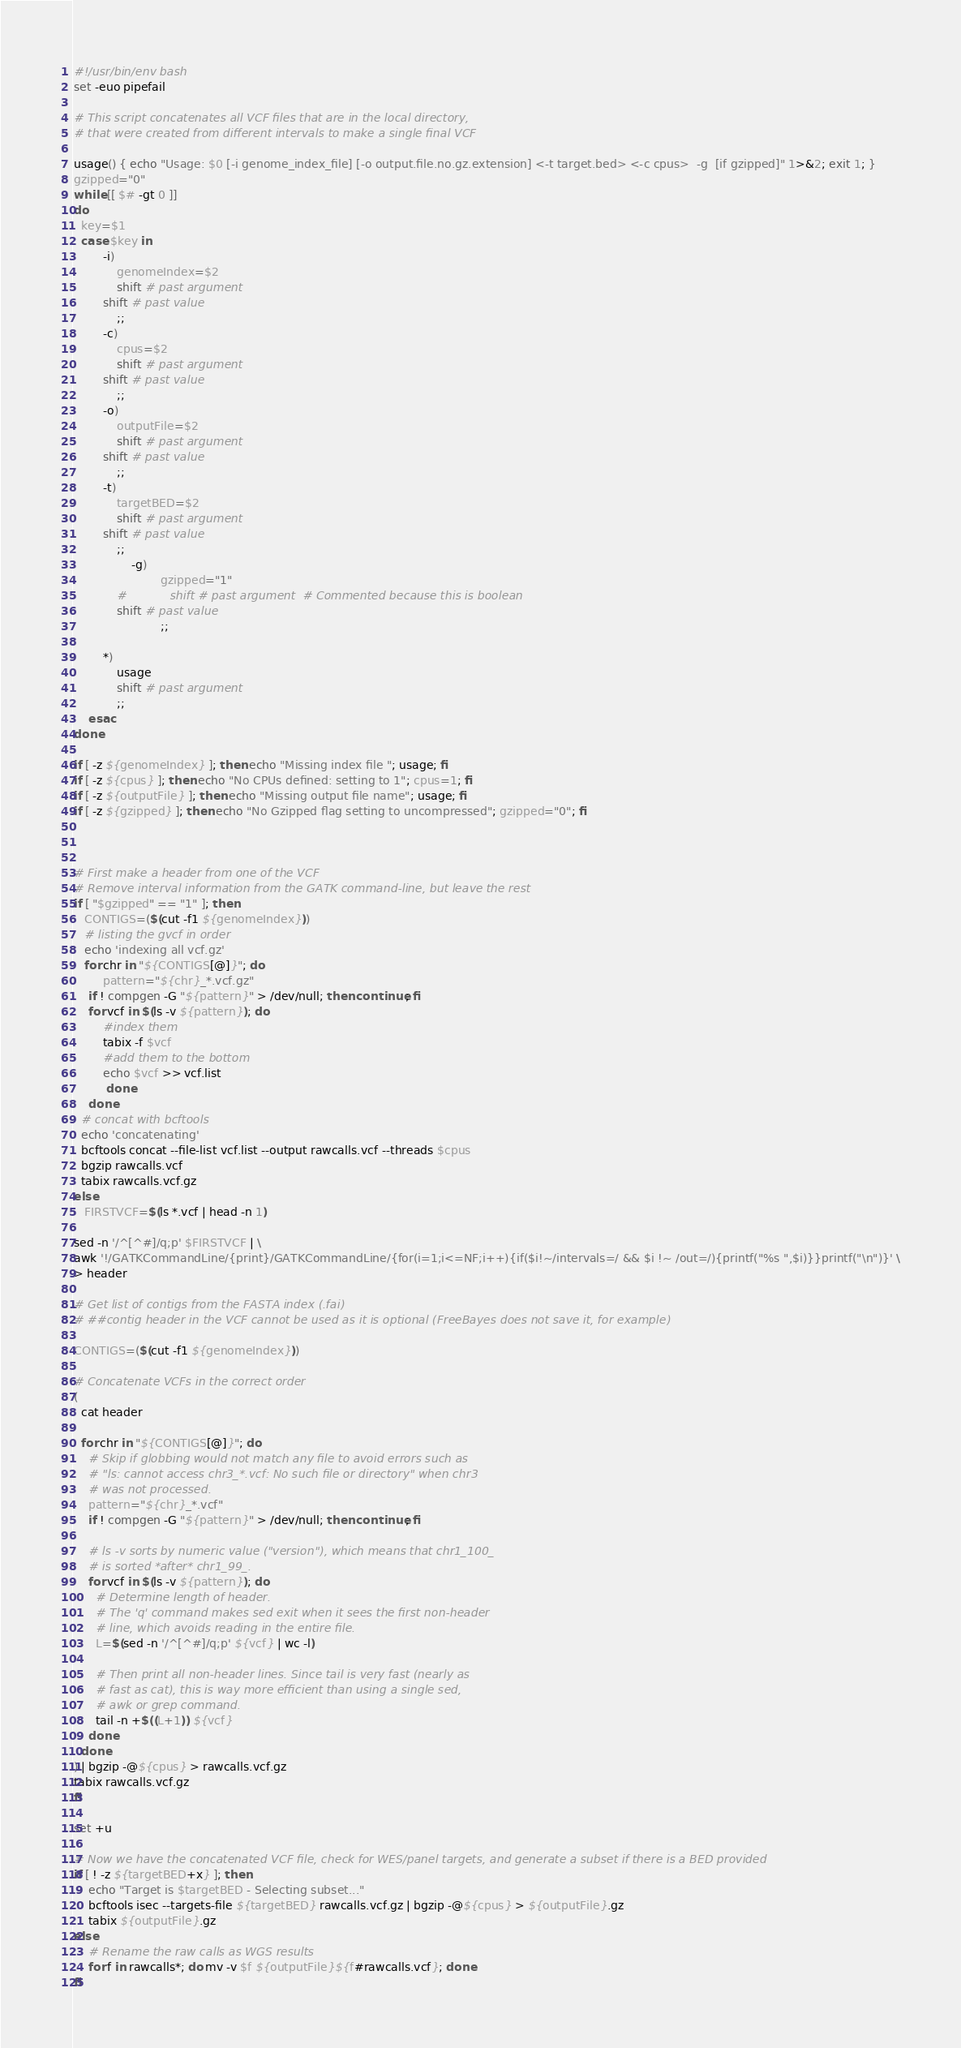Convert code to text. <code><loc_0><loc_0><loc_500><loc_500><_Bash_>#!/usr/bin/env bash
set -euo pipefail

# This script concatenates all VCF files that are in the local directory,
# that were created from different intervals to make a single final VCF

usage() { echo "Usage: $0 [-i genome_index_file] [-o output.file.no.gz.extension] <-t target.bed> <-c cpus>  -g  [if gzipped]" 1>&2; exit 1; }
gzipped="0"
while [[ $# -gt 0 ]]
do
  key=$1
  case $key in
		-i)
			genomeIndex=$2
			shift # past argument
	    shift # past value
			;;
		-c)
			cpus=$2
			shift # past argument
	    shift # past value
			;;
		-o)
			outputFile=$2
			shift # past argument
	    shift # past value
			;;
		-t)
			targetBED=$2
			shift # past argument
	    shift # past value
			;;
                -g)
                        gzipped="1"
            #            shift # past argument  # Commented because this is boolean
            shift # past value
                        ;;

		*)
			usage
			shift # past argument
			;;
	esac
done

if [ -z ${genomeIndex} ]; then echo "Missing index file "; usage; fi
if [ -z ${cpus} ]; then echo "No CPUs defined: setting to 1"; cpus=1; fi
if [ -z ${outputFile} ]; then echo "Missing output file name"; usage; fi
if [ -z ${gzipped} ]; then echo "No Gzipped flag setting to uncompressed"; gzipped="0"; fi



# First make a header from one of the VCF
# Remove interval information from the GATK command-line, but leave the rest
if [ "$gzipped" == "1" ]; then
   CONTIGS=($(cut -f1 ${genomeIndex}))
   # listing the gvcf in order 
   echo 'indexing all vcf.gz'
   for chr in "${CONTIGS[@]}"; do
        pattern="${chr}_*.vcf.gz"
	if ! compgen -G "${pattern}" > /dev/null; then continue; fi
	for vcf in $(ls -v ${pattern}); do
	    #index them 
	    tabix -f $vcf
	    #add them to the bottom 
	    echo $vcf >> vcf.list
         done
    done
  # concat with bcftools
  echo 'concatenating' 
  bcftools concat --file-list vcf.list --output rawcalls.vcf --threads $cpus
  bgzip rawcalls.vcf
  tabix rawcalls.vcf.gz
else
   FIRSTVCF=$(ls *.vcf | head -n 1)

sed -n '/^[^#]/q;p' $FIRSTVCF | \
awk '!/GATKCommandLine/{print}/GATKCommandLine/{for(i=1;i<=NF;i++){if($i!~/intervals=/ && $i !~ /out=/){printf("%s ",$i)}}printf("\n")}' \
> header

# Get list of contigs from the FASTA index (.fai)
# ##contig header in the VCF cannot be used as it is optional (FreeBayes does not save it, for example)

CONTIGS=($(cut -f1 ${genomeIndex}))

# Concatenate VCFs in the correct order
(
  cat header

  for chr in "${CONTIGS[@]}"; do
    # Skip if globbing would not match any file to avoid errors such as
    # "ls: cannot access chr3_*.vcf: No such file or directory" when chr3
    # was not processed.
    pattern="${chr}_*.vcf"
    if ! compgen -G "${pattern}" > /dev/null; then continue; fi

    # ls -v sorts by numeric value ("version"), which means that chr1_100_
    # is sorted *after* chr1_99_.
    for vcf in $(ls -v ${pattern}); do
      # Determine length of header.
      # The 'q' command makes sed exit when it sees the first non-header
      # line, which avoids reading in the entire file.
      L=$(sed -n '/^[^#]/q;p' ${vcf} | wc -l)

      # Then print all non-header lines. Since tail is very fast (nearly as
      # fast as cat), this is way more efficient than using a single sed,
      # awk or grep command.
      tail -n +$((L+1)) ${vcf}
    done
  done
) | bgzip -@${cpus} > rawcalls.vcf.gz
tabix rawcalls.vcf.gz
fi 

set +u

# Now we have the concatenated VCF file, check for WES/panel targets, and generate a subset if there is a BED provided
if [ ! -z ${targetBED+x} ]; then
	echo "Target is $targetBED - Selecting subset..."
	bcftools isec --targets-file ${targetBED} rawcalls.vcf.gz | bgzip -@${cpus} > ${outputFile}.gz
	tabix ${outputFile}.gz
else
	# Rename the raw calls as WGS results
	for f in rawcalls*; do mv -v $f ${outputFile}${f#rawcalls.vcf}; done
fi
</code> 